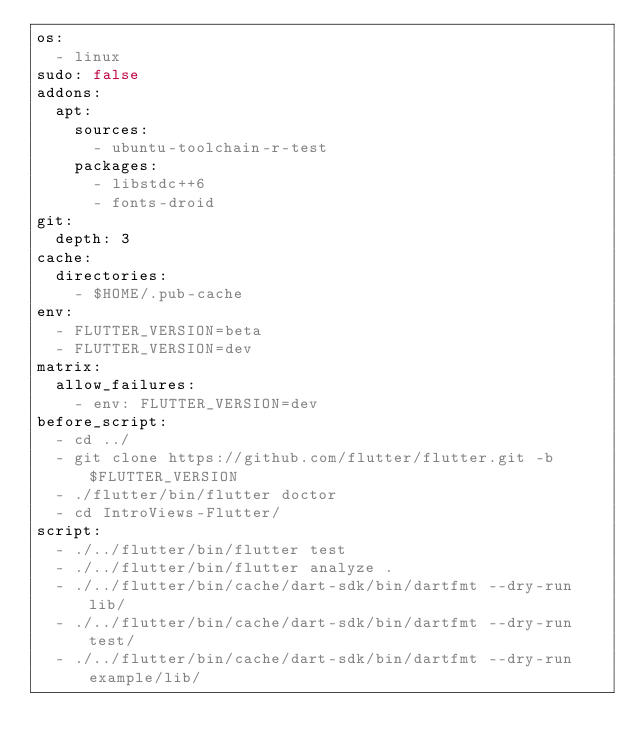Convert code to text. <code><loc_0><loc_0><loc_500><loc_500><_YAML_>os:
  - linux
sudo: false
addons:
  apt:
    sources:
      - ubuntu-toolchain-r-test
    packages:
      - libstdc++6
      - fonts-droid
git:
  depth: 3
cache:
  directories:
    - $HOME/.pub-cache
env:
  - FLUTTER_VERSION=beta
  - FLUTTER_VERSION=dev
matrix:
  allow_failures:
    - env: FLUTTER_VERSION=dev
before_script:
  - cd ../
  - git clone https://github.com/flutter/flutter.git -b $FLUTTER_VERSION
  - ./flutter/bin/flutter doctor
  - cd IntroViews-Flutter/
script:
  - ./../flutter/bin/flutter test
  - ./../flutter/bin/flutter analyze .
  - ./../flutter/bin/cache/dart-sdk/bin/dartfmt --dry-run lib/
  - ./../flutter/bin/cache/dart-sdk/bin/dartfmt --dry-run test/
  - ./../flutter/bin/cache/dart-sdk/bin/dartfmt --dry-run example/lib/</code> 